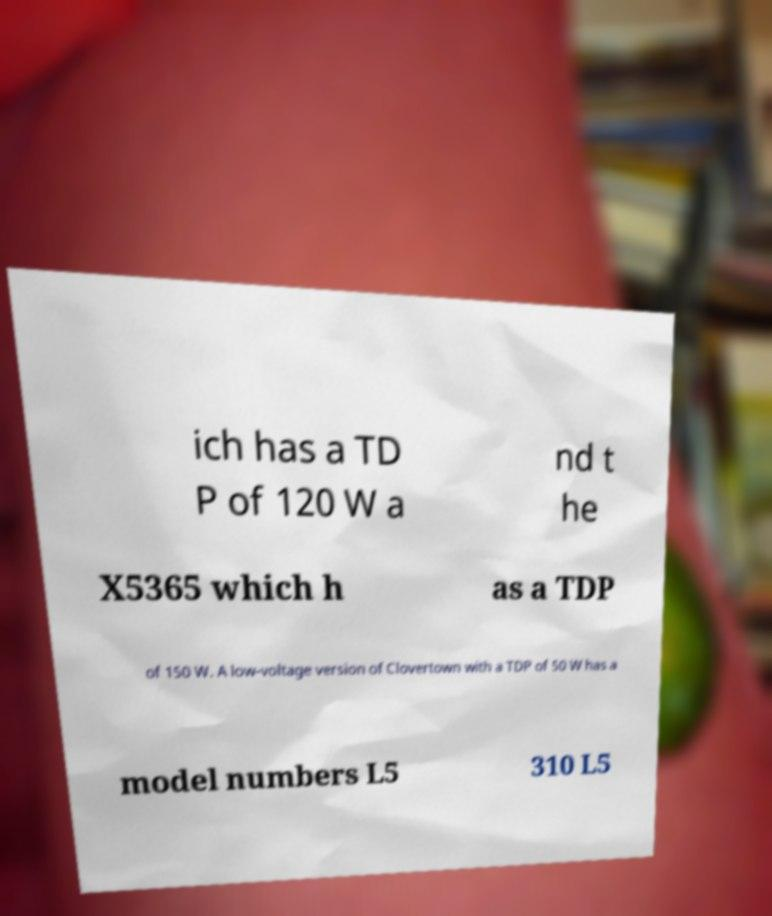Can you accurately transcribe the text from the provided image for me? ich has a TD P of 120 W a nd t he X5365 which h as a TDP of 150 W. A low-voltage version of Clovertown with a TDP of 50 W has a model numbers L5 310 L5 